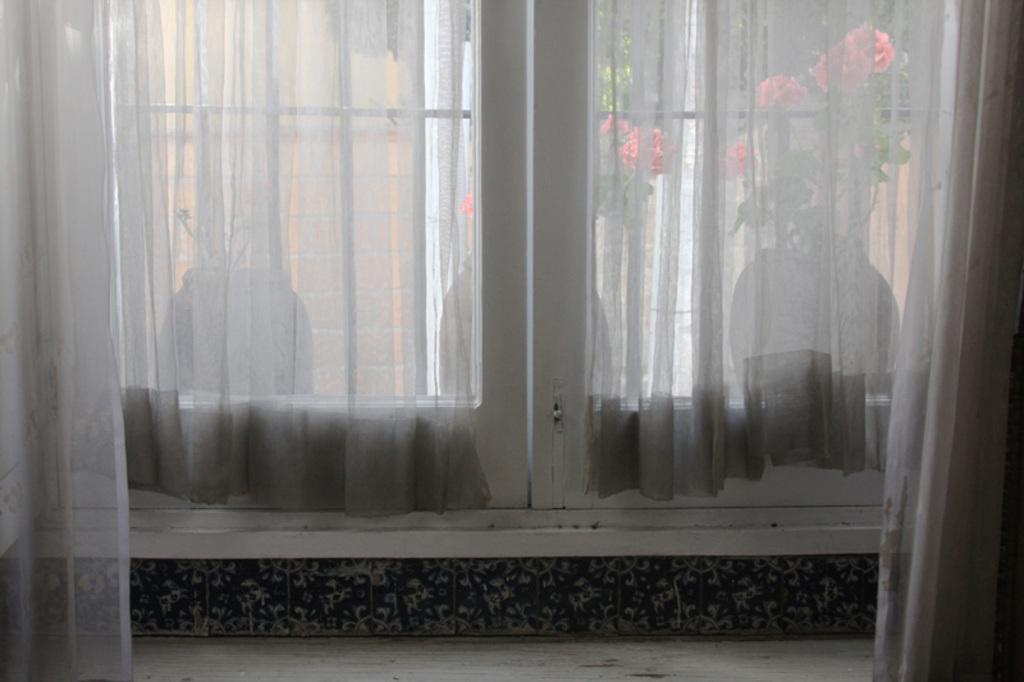Can you describe this image briefly? We can see curtains and window, through this window we can see plants with pots and flowers. 